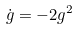Convert formula to latex. <formula><loc_0><loc_0><loc_500><loc_500>\dot { g } = - 2 g ^ { 2 }</formula> 